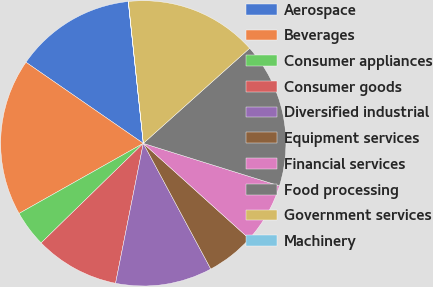Convert chart to OTSL. <chart><loc_0><loc_0><loc_500><loc_500><pie_chart><fcel>Aerospace<fcel>Beverages<fcel>Consumer appliances<fcel>Consumer goods<fcel>Diversified industrial<fcel>Equipment services<fcel>Financial services<fcel>Food processing<fcel>Government services<fcel>Machinery<nl><fcel>13.69%<fcel>17.8%<fcel>4.12%<fcel>9.59%<fcel>10.96%<fcel>5.49%<fcel>6.85%<fcel>16.43%<fcel>15.06%<fcel>0.01%<nl></chart> 